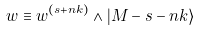Convert formula to latex. <formula><loc_0><loc_0><loc_500><loc_500>w \equiv w ^ { ( s + n k ) } \wedge | M - s - n k \rangle</formula> 